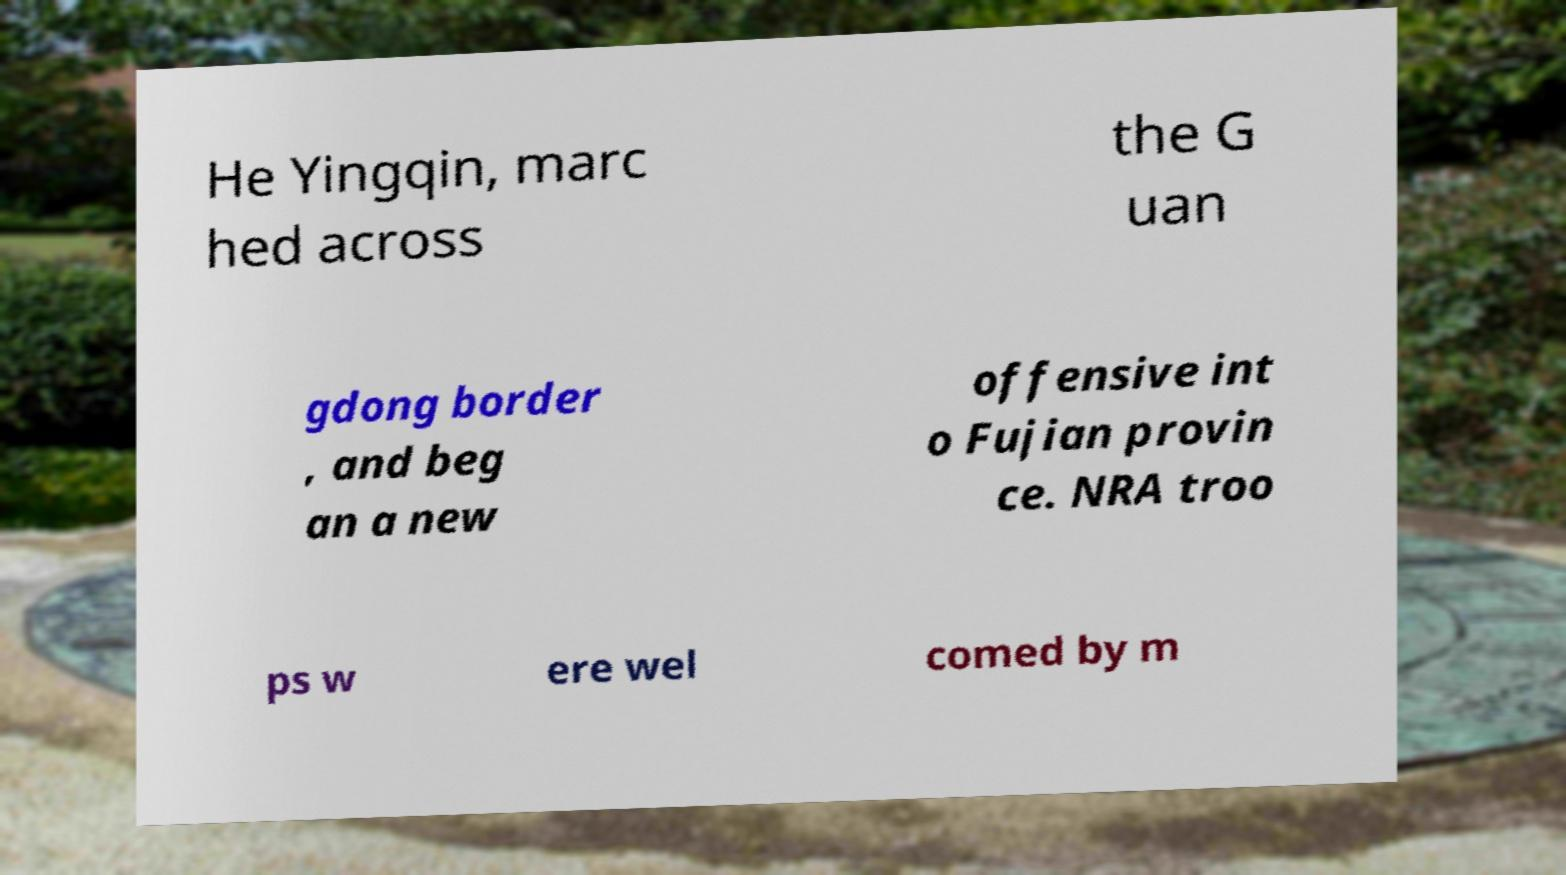Can you accurately transcribe the text from the provided image for me? He Yingqin, marc hed across the G uan gdong border , and beg an a new offensive int o Fujian provin ce. NRA troo ps w ere wel comed by m 